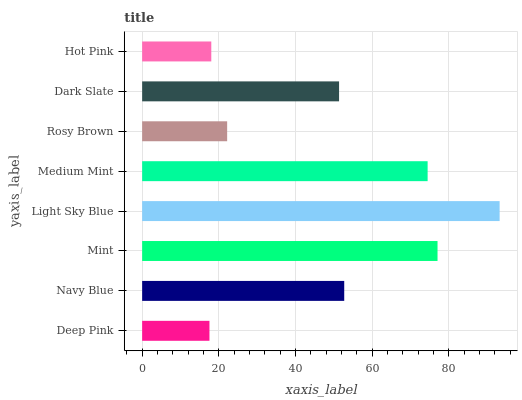Is Deep Pink the minimum?
Answer yes or no. Yes. Is Light Sky Blue the maximum?
Answer yes or no. Yes. Is Navy Blue the minimum?
Answer yes or no. No. Is Navy Blue the maximum?
Answer yes or no. No. Is Navy Blue greater than Deep Pink?
Answer yes or no. Yes. Is Deep Pink less than Navy Blue?
Answer yes or no. Yes. Is Deep Pink greater than Navy Blue?
Answer yes or no. No. Is Navy Blue less than Deep Pink?
Answer yes or no. No. Is Navy Blue the high median?
Answer yes or no. Yes. Is Dark Slate the low median?
Answer yes or no. Yes. Is Light Sky Blue the high median?
Answer yes or no. No. Is Light Sky Blue the low median?
Answer yes or no. No. 